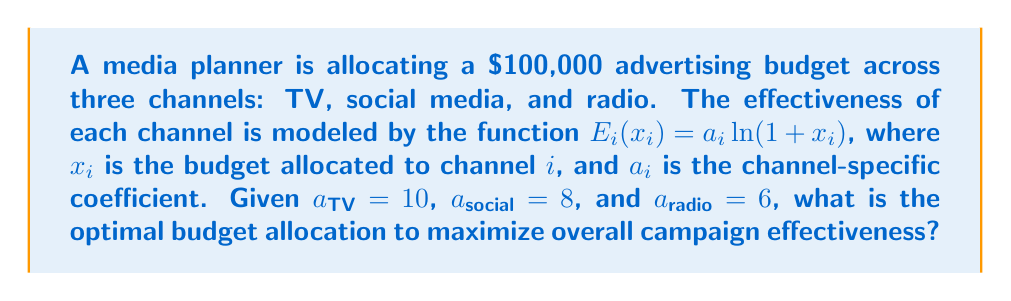Show me your answer to this math problem. To solve this problem, we'll use the method of Lagrange multipliers:

1) Define the objective function:
   $$E_{total} = E_{TV} + E_{social} + E_{radio}$$
   $$E_{total} = 10\ln(1+x_{TV}) + 8\ln(1+x_{social}) + 6\ln(1+x_{radio})$$

2) Constraint equation:
   $$x_{TV} + x_{social} + x_{radio} = 100,000$$

3) Form the Lagrangian:
   $$L = 10\ln(1+x_{TV}) + 8\ln(1+x_{social}) + 6\ln(1+x_{radio}) - \lambda(x_{TV} + x_{social} + x_{radio} - 100,000)$$

4) Take partial derivatives and set them equal to zero:
   $$\frac{\partial L}{\partial x_{TV}} = \frac{10}{1+x_{TV}} - \lambda = 0$$
   $$\frac{\partial L}{\partial x_{social}} = \frac{8}{1+x_{social}} - \lambda = 0$$
   $$\frac{\partial L}{\partial x_{radio}} = \frac{6}{1+x_{radio}} - \lambda = 0$$

5) From these equations, we can derive:
   $$1+x_{TV} = \frac{10}{\lambda}$$
   $$1+x_{social} = \frac{8}{\lambda}$$
   $$1+x_{radio} = \frac{6}{\lambda}$$

6) Substitute these into the constraint equation:
   $$(\frac{10}{\lambda} - 1) + (\frac{8}{\lambda} - 1) + (\frac{6}{\lambda} - 1) = 100,000$$
   $$\frac{24}{\lambda} - 3 = 100,000$$
   $$\frac{24}{\lambda} = 100,003$$
   $$\lambda = \frac{24}{100,003} \approx 0.00024$$

7) Now we can solve for each $x_i$:
   $$x_{TV} = \frac{10}{0.00024} - 1 \approx 41,666$$
   $$x_{social} = \frac{8}{0.00024} - 1 \approx 33,333$$
   $$x_{radio} = \frac{6}{0.00024} - 1 \approx 25,000$$

Therefore, the optimal allocation is approximately $41,666 for TV, $33,333 for social media, and $25,000 for radio.
Answer: TV: $41,666, Social Media: $33,333, Radio: $25,000 